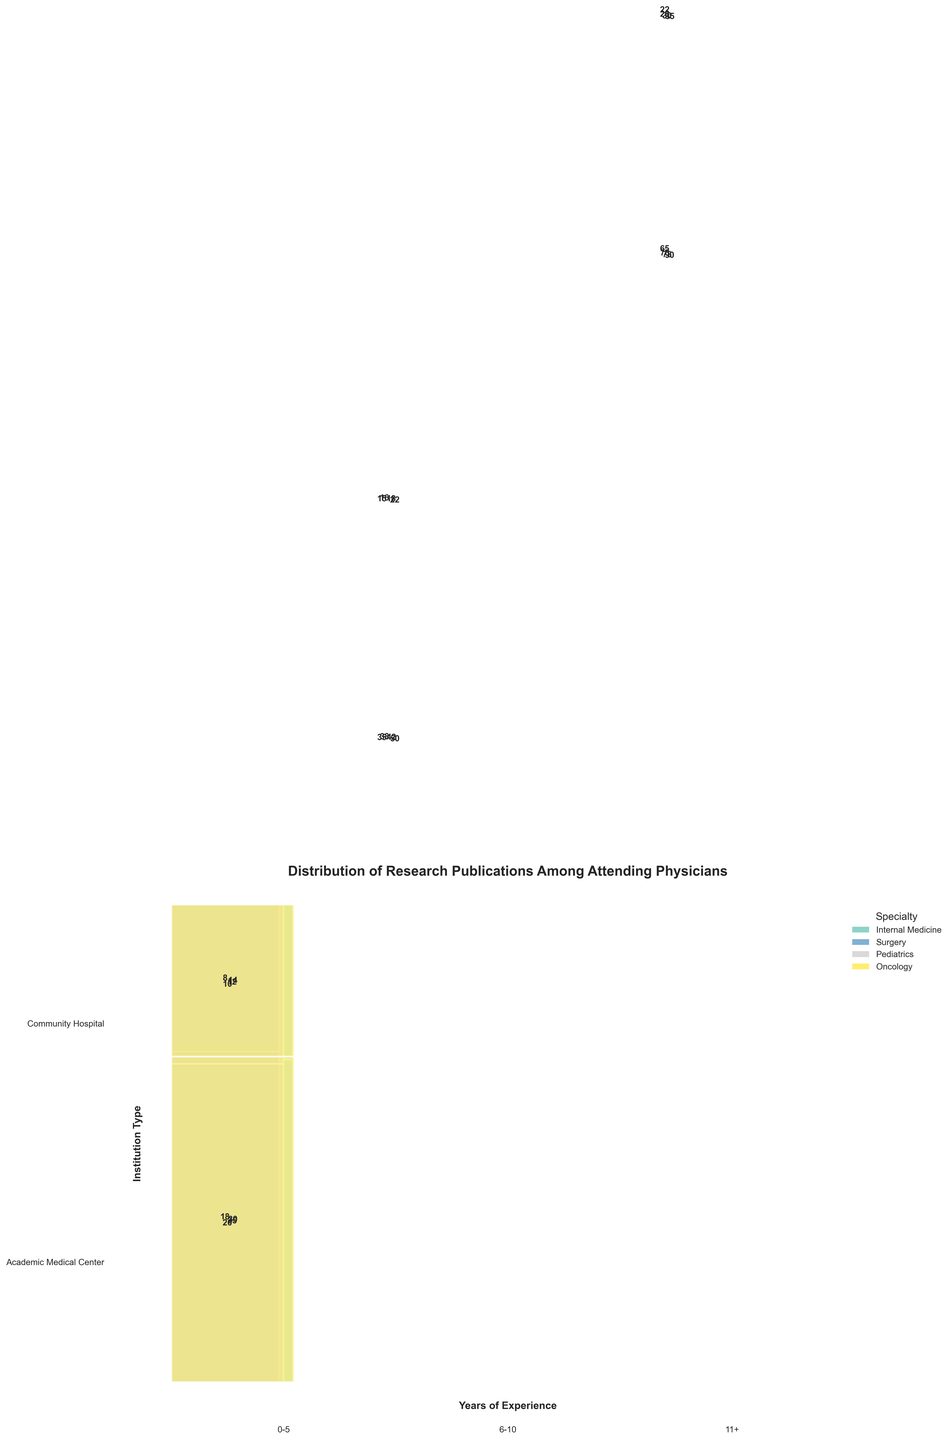What specialty has the most research publications? The total research publications for each specialty can be visually identified by the cumulative heights of the respective bars in the mosaic plot. Oncology appears to have the tallest bars combined for all years of experience and institution types.
Answer: Oncology How do the research publications compare between Academic Medical Centers and Community Hospitals for Internal Medicine with 6-10 years of experience? By looking at the segment widths for 6-10 years of experience in Internal Medicine, we can see that the segment for Academic Medical Centers is wider than that for Community Hospitals. This indicates Academic Medical Centers have more publications.
Answer: Academic Medical Centers have more publications Which specialty has the fewest publications in the 0-5 years of experience bracket? Compare the heights of the bars corresponding to the 0-5 years of experience bracket for each specialty. Surgery appears to have the smallest combined bar height for this experience range.
Answer: Surgery How do the publications from 11+ years of experience in Pediatrics compare between Academic Medical Centers and Community Hospitals? For the 11+ years of experience in Pediatrics, the height of the publication bar for Academic Medical Centers is significantly larger than that for Community Hospitals.
Answer: Academic Medical Centers have more publications What specialty and institution type combination has the highest number of publications for the 11+ years experience category? Within the 11+ years of experience category, comparing the height of each bar, the tallest bar corresponds to Oncology at Academic Medical Centers.
Answer: Oncology at Academic Medical Centers What is the total number of publications for Surgery at Community Hospitals across all years of experience? The totals can be calculated by summing the publication counts in the Surgery and Community Hospital row for all years of experience (8 + 15 + 22 = 45).
Answer: 45 publications Which institution type has more publications overall in the 6-10 years experience bracket? Adding the heights of the corresponding segments for each institution type in the 6-10 years experience bracket, Academic Medical Centers have more publications than Community Hospitals.
Answer: Academic Medical Centers How does the trend of publications in Pediatrics change with experience at Academic Medical Centers? Observing the height of bars for Pediatrics at Academic Medical Centers, the number of publications increases with years of experience (from 20 to 38 to 70).
Answer: Publications increase with experience Which specialty has the most equal distribution of publications between the two institution types for the 0-5 years experience category? Comparing the bars for the 0-5 years experience category, Oncology shows relatively similar heights for Academic Medical Centers and Community Hospitals.
Answer: Oncology How much greater are the publications in Oncology with 11+ years of experience at Academic Medical Centers compared to Community Hospitals? Subtract the publications at Community Hospitals (35) from those at Academic Medical Centers (90) for Oncology with 11+ years of experience.
Answer: 55 more publications 